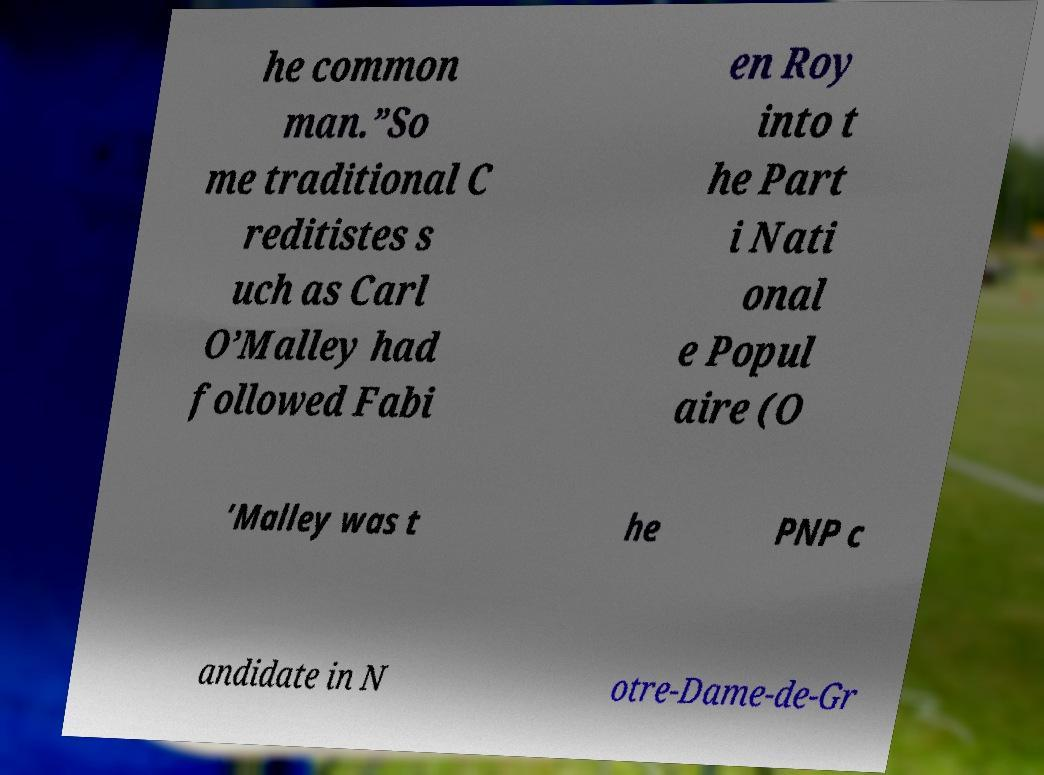I need the written content from this picture converted into text. Can you do that? he common man.”So me traditional C reditistes s uch as Carl O’Malley had followed Fabi en Roy into t he Part i Nati onal e Popul aire (O ’Malley was t he PNP c andidate in N otre-Dame-de-Gr 